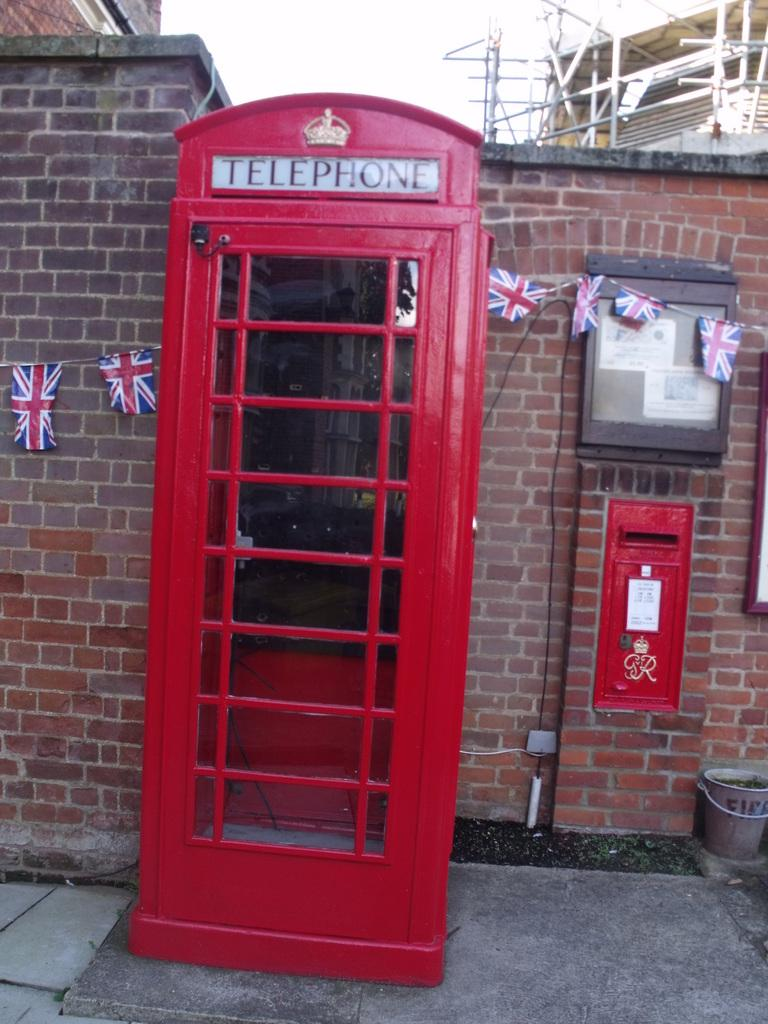What structure is the main subject of the image? There is a telephone booth in the image. What is behind the telephone booth? The telephone booth is in front of a brick wall. What can be seen above the telephone booth? The sky is visible above the telephone booth. What type of picture is hanging on the chin of the person in the image? There is no person or picture hanging on a chin present in the image; it features a telephone booth in front of a brick wall with the sky visible above. 